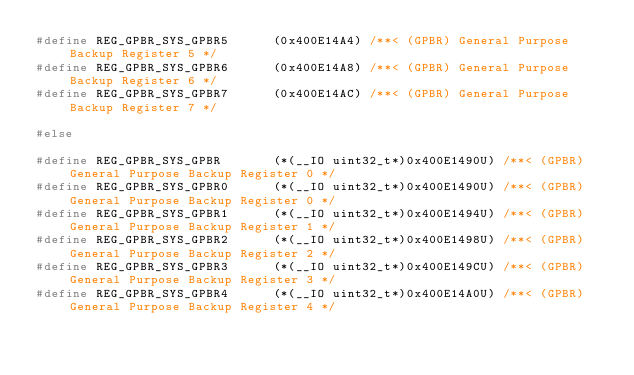Convert code to text. <code><loc_0><loc_0><loc_500><loc_500><_C_>#define REG_GPBR_SYS_GPBR5      (0x400E14A4) /**< (GPBR) General Purpose Backup Register 5 */
#define REG_GPBR_SYS_GPBR6      (0x400E14A8) /**< (GPBR) General Purpose Backup Register 6 */
#define REG_GPBR_SYS_GPBR7      (0x400E14AC) /**< (GPBR) General Purpose Backup Register 7 */

#else

#define REG_GPBR_SYS_GPBR       (*(__IO uint32_t*)0x400E1490U) /**< (GPBR) General Purpose Backup Register 0 */
#define REG_GPBR_SYS_GPBR0      (*(__IO uint32_t*)0x400E1490U) /**< (GPBR) General Purpose Backup Register 0 */
#define REG_GPBR_SYS_GPBR1      (*(__IO uint32_t*)0x400E1494U) /**< (GPBR) General Purpose Backup Register 1 */
#define REG_GPBR_SYS_GPBR2      (*(__IO uint32_t*)0x400E1498U) /**< (GPBR) General Purpose Backup Register 2 */
#define REG_GPBR_SYS_GPBR3      (*(__IO uint32_t*)0x400E149CU) /**< (GPBR) General Purpose Backup Register 3 */
#define REG_GPBR_SYS_GPBR4      (*(__IO uint32_t*)0x400E14A0U) /**< (GPBR) General Purpose Backup Register 4 */</code> 